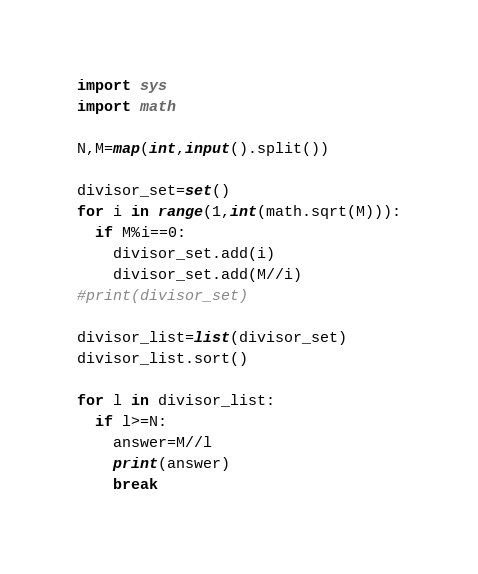Convert code to text. <code><loc_0><loc_0><loc_500><loc_500><_Python_>import sys
import math

N,M=map(int,input().split())

divisor_set=set()
for i in range(1,int(math.sqrt(M))):
  if M%i==0:
    divisor_set.add(i)
    divisor_set.add(M//i)
#print(divisor_set)

divisor_list=list(divisor_set)
divisor_list.sort()

for l in divisor_list:
  if l>=N:
    answer=M//l
    print(answer)
    break
</code> 